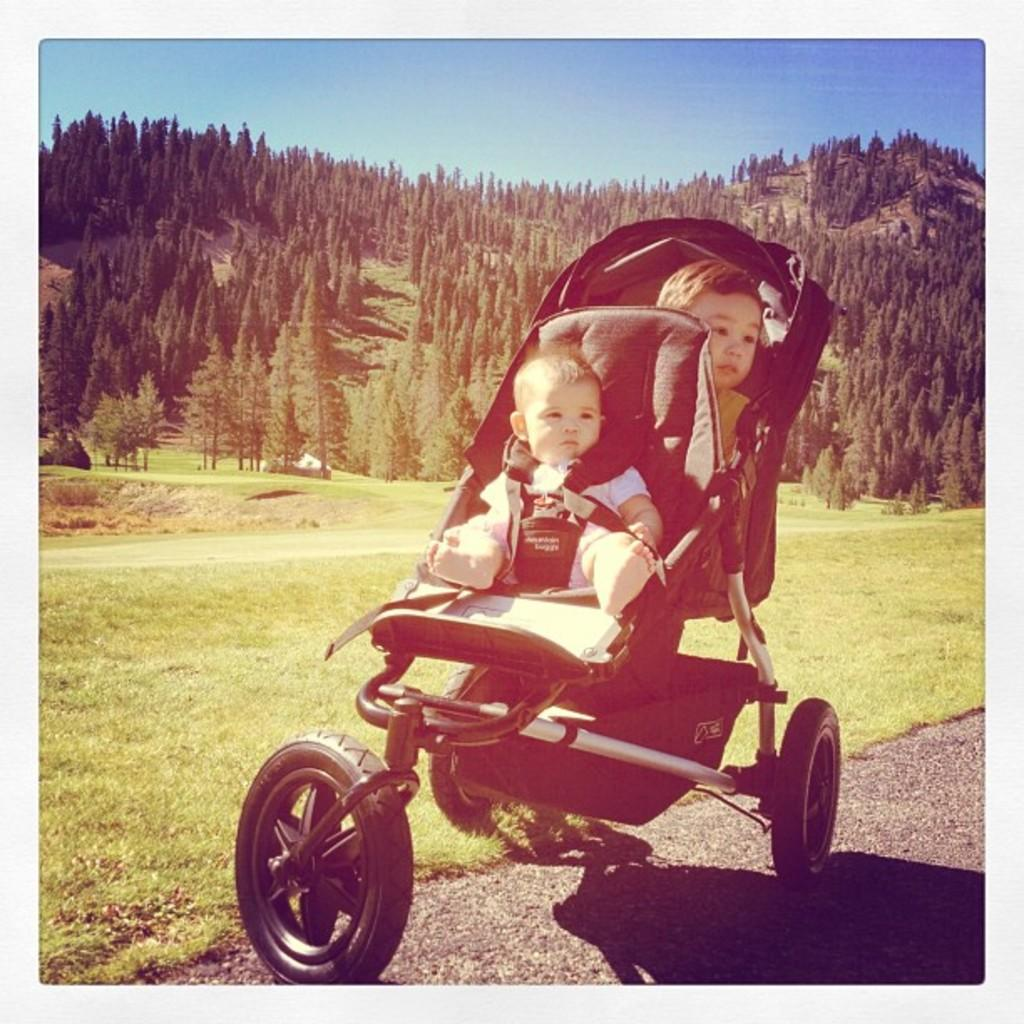How many kids are in the image? There are two kids in the image. What are the kids sitting on? The kids are sitting on a baby trolley. What type of surface is at the bottom of the image? There is grass on the surface at the bottom of the image. What can be seen in the background of the image? There are trees and the sky visible in the background of the image. What type of impulse can be seen affecting the baby trolley in the image? There is no impulse affecting the baby trolley in the image; it is stationary with the kids sitting on it. Can you tell me the total cost of the items purchased by the kids in the image? There is no receipt or indication of any purchases in the image. 